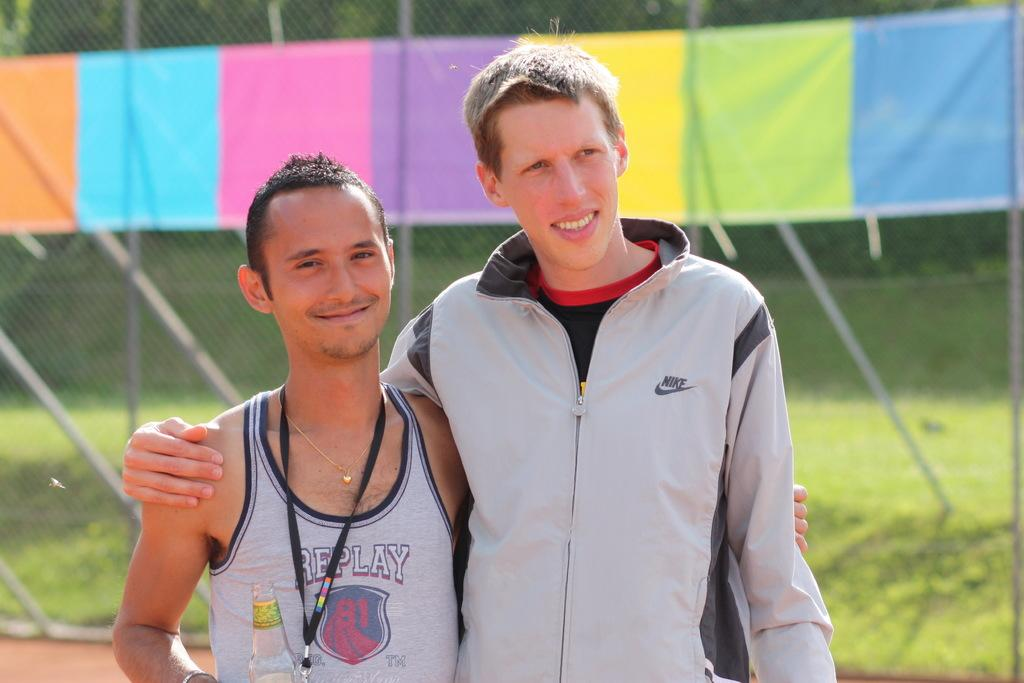<image>
Give a short and clear explanation of the subsequent image. two friend wearing sports clothes for Nike and Replay 